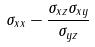Convert formula to latex. <formula><loc_0><loc_0><loc_500><loc_500>\sigma _ { x x } - \frac { \sigma _ { x z } \sigma _ { x y } } { \sigma _ { y z } }</formula> 